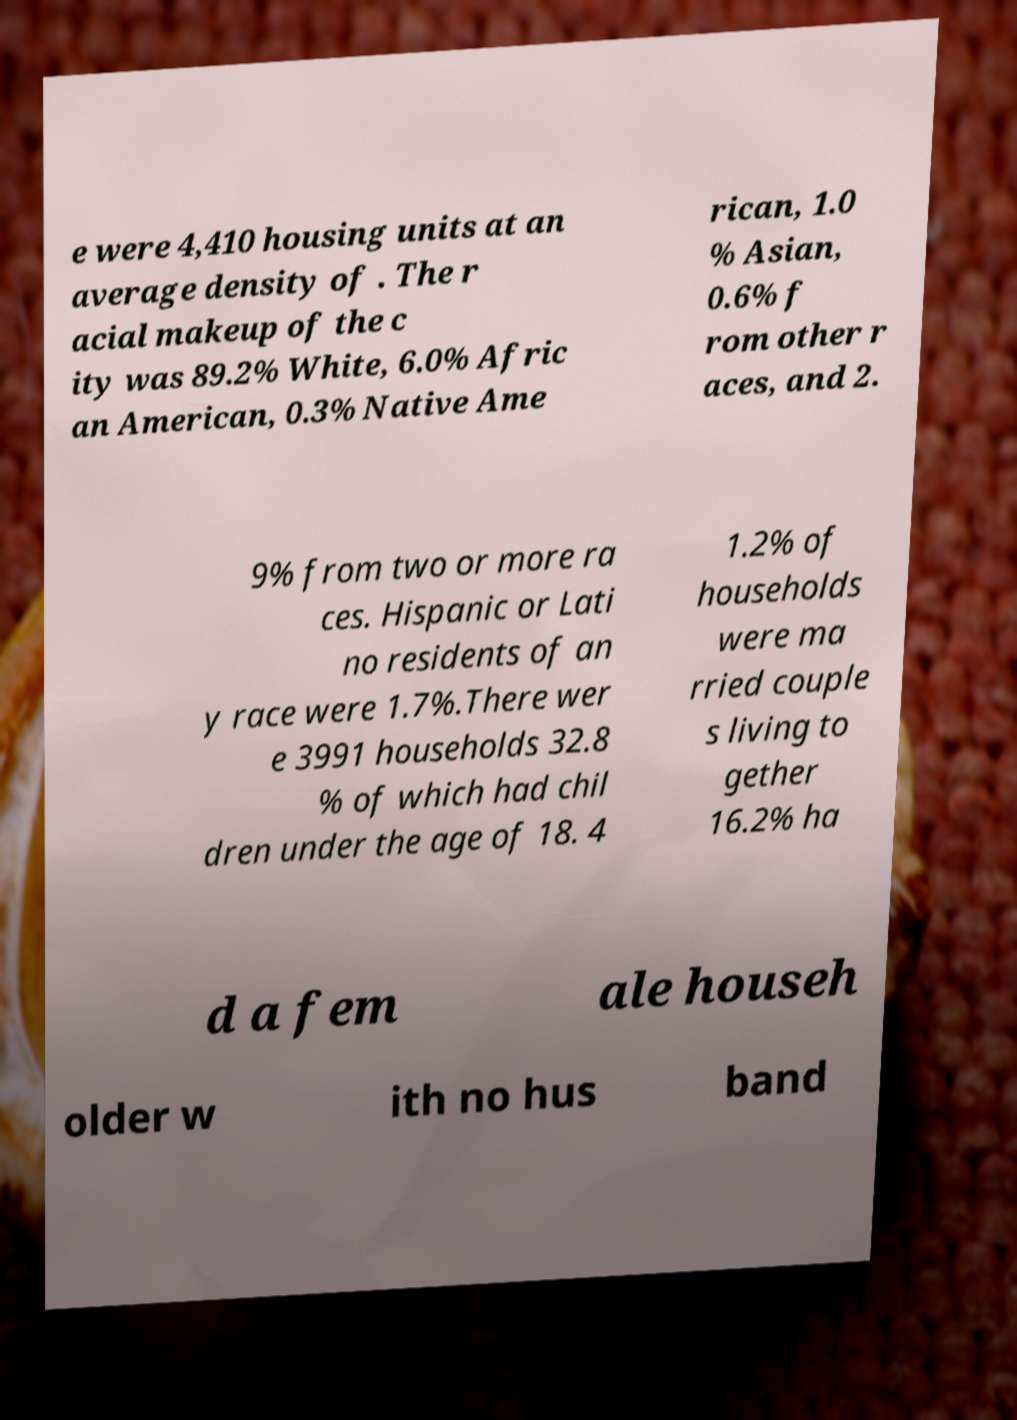What messages or text are displayed in this image? I need them in a readable, typed format. e were 4,410 housing units at an average density of . The r acial makeup of the c ity was 89.2% White, 6.0% Afric an American, 0.3% Native Ame rican, 1.0 % Asian, 0.6% f rom other r aces, and 2. 9% from two or more ra ces. Hispanic or Lati no residents of an y race were 1.7%.There wer e 3991 households 32.8 % of which had chil dren under the age of 18. 4 1.2% of households were ma rried couple s living to gether 16.2% ha d a fem ale househ older w ith no hus band 